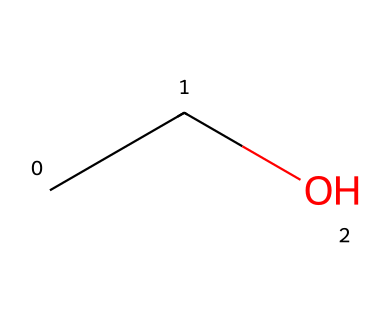What is the molecular formula of this compound? The SMILES representation "CCO" indicates a chain of two carbon atoms (C) and one oxygen atom (O). The molecular formula is derived from counting these atoms, which gives us C2H6O considering the hydrogen atoms that balance the carbon and oxygen.
Answer: C2H6O How many carbon atoms are present in this chemical? By analyzing the SMILES "CCO", we see there are two 'C' symbols, indicating there are two carbon atoms in the structure.
Answer: 2 Does ethanol have any acidic properties? Ethanol, represented as "CCO", lacks functional groups such as -COOH (carboxylic acid) that exhibit acidity, indicating it does not possess notable acidic properties.
Answer: No Is ethanol a polar molecule? The presence of the -OH (hydroxyl) group in the structure indicates that ethanol has a significant polarity due to the difference in electronegativity between oxygen and hydrogen, which leads to its polar nature.
Answer: Yes What type of intermolecular forces prevail in ethanol? Ethanol contains hydroxyl groups, which allows for hydrogen bonding between molecules. Hydrogen bonding is a key intermolecular force that is stronger than van der Waals forces, thus dominating in ethanol.
Answer: Hydrogen bonding How many hydrogen atoms are bonded to the carbon atoms in ethanol? In the structure "CCO", each of the two carbon atoms is bonded to three hydrogen atoms collectively, resulting in a total of six hydrogen bonds in the complete structure.
Answer: 6 What type of chemical is ethanol classified as? Ethanol is categorized as an alcohol due to the presence of the -OH functional group in its structure, which is characteristic of alcohols.
Answer: Alcohol 